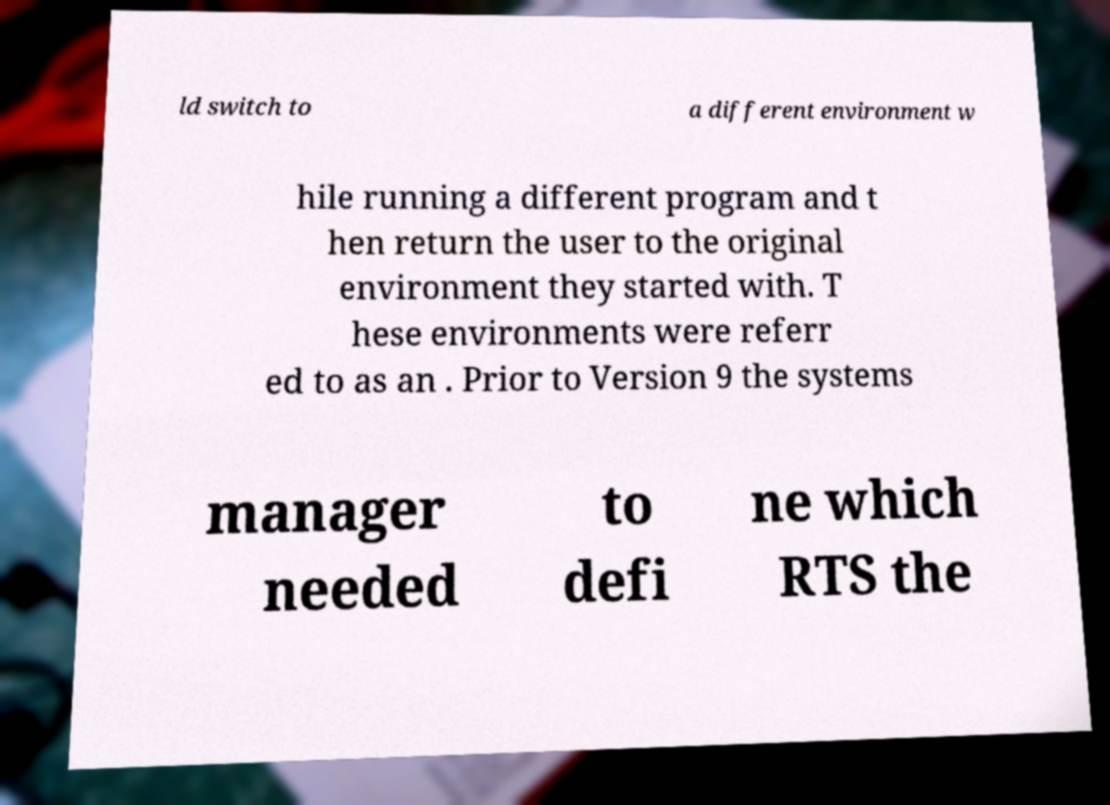For documentation purposes, I need the text within this image transcribed. Could you provide that? ld switch to a different environment w hile running a different program and t hen return the user to the original environment they started with. T hese environments were referr ed to as an . Prior to Version 9 the systems manager needed to defi ne which RTS the 